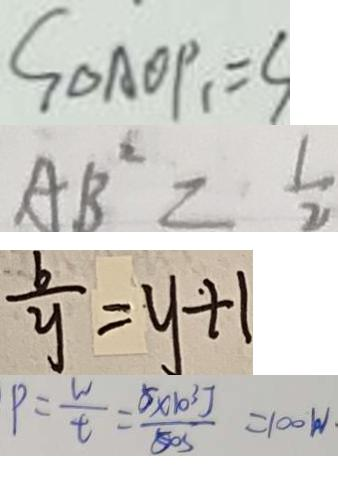<formula> <loc_0><loc_0><loc_500><loc_500>S _ { \Delta A O P _ { 1 } } = S 
 A B ^ { 2 } = \frac { 1 } { 2 } 
 \frac { b } { y } = y + 1 
 p = \frac { w } { t } = \frac { 5 \times 1 0 ^ { 3 } J } { 5 0 s } = 1 0 0 w</formula> 